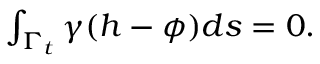<formula> <loc_0><loc_0><loc_500><loc_500>\begin{array} { r } { \int _ { \Gamma _ { t } } \gamma ( h - \phi ) d s = 0 . } \end{array}</formula> 